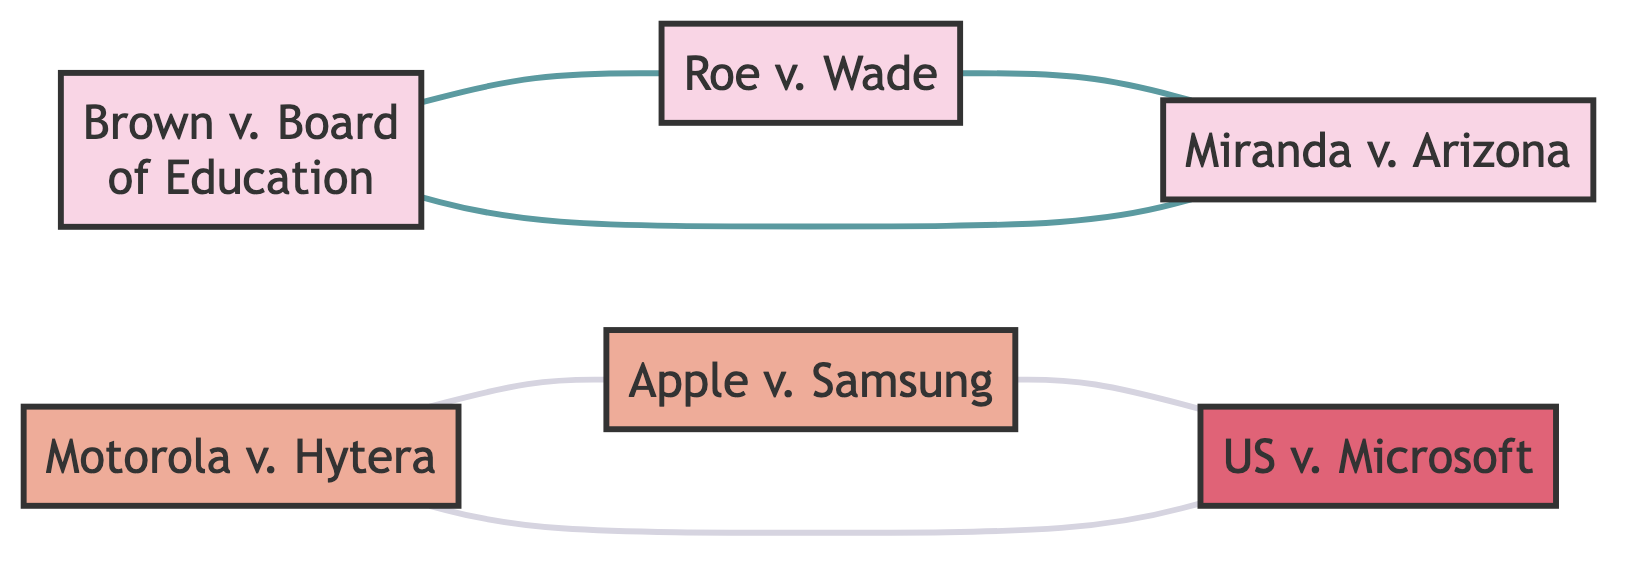What are the legal cases represented in the diagram? The diagram shows three legal cases: Brown v. Board of Education, Roe v. Wade, and Miranda v. Arizona. These are identified as nodes 1, 2, and 3.
Answer: Brown v. Board of Education, Roe v. Wade, Miranda v. Arizona How many patent cases are in the diagram? There are two patent cases represented by the nodes: Motorola Solutions, Inc. v. Hytera Communications Corp. and Apple Inc. v. Samsung Electronics Co., which correspond to nodes 4 and 5.
Answer: 2 Which legal case has co-citation links with both Brown v. Board of Education and Miranda v. Arizona? By checking the edges connected to node 1 (Brown v. Board of Education), we see it is co-cited with node 2 (Roe v. Wade) and also node 3 (Miranda v. Arizona). Roe v. Wade serves as the connecting node indicating co-citation among the three cases.
Answer: Roe v. Wade What is the relationship between Apple Inc. v. Samsung Electronics Co. and United States v. Microsoft Corp.? An examination of the edges shows that there is a co-citation link directly connecting Apple Inc. v. Samsung Electronics Co. (node 5) to United States v. Microsoft Corp. (node 6), indicating they are cited together in legal contexts.
Answer: Co-citation How many total edges connect the patent cases in the diagram? There are two edges that connect the patent cases: one between Motorola Solutions, Inc. v. Hytera Communications Corp. (node 4) and Apple Inc. v. Samsung Electronics Co. (node 5), and the other between Apple Inc. v. Samsung Electronics Co. (node 5) and United States v. Microsoft Corp. (node 6). Thus, the total count of edges connecting the patent cases is two.
Answer: 2 Which node is the starting point for co-citation relations among the legal cases? Starting from node 1 (Brown v. Board of Education), which has relations with both node 2 (Roe v. Wade) and node 3 (Miranda v. Arizona), it is evident that node 1 serves as a key starting point for co-citation among these cases.
Answer: Brown v. Board of Education What is the total number of nodes in the diagram? A sum of all different cases represented reveals that there are six individual nodes in the diagram: three legal cases, two patent cases, and one antitrust case.
Answer: 6 Which type of case is represented by node 4? Node 4 specifically refers to the case Motorola Solutions, Inc. v. Hytera Communications Corp., which is categorized as a patent case as indicated by its classification in the diagram.
Answer: Patent case 